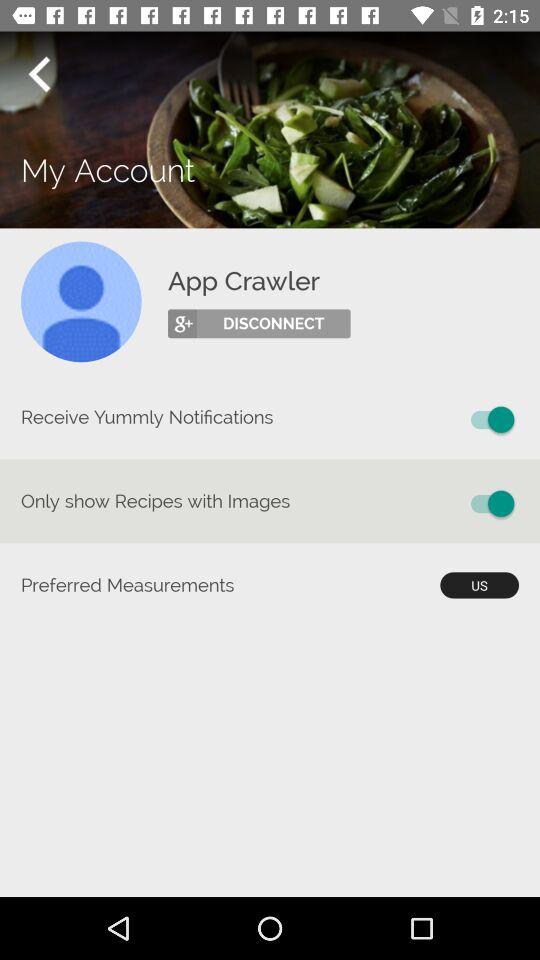Which options have "on" status? The options are "Receive Yummly Notifications" and "Only Show Recipes with Images". 